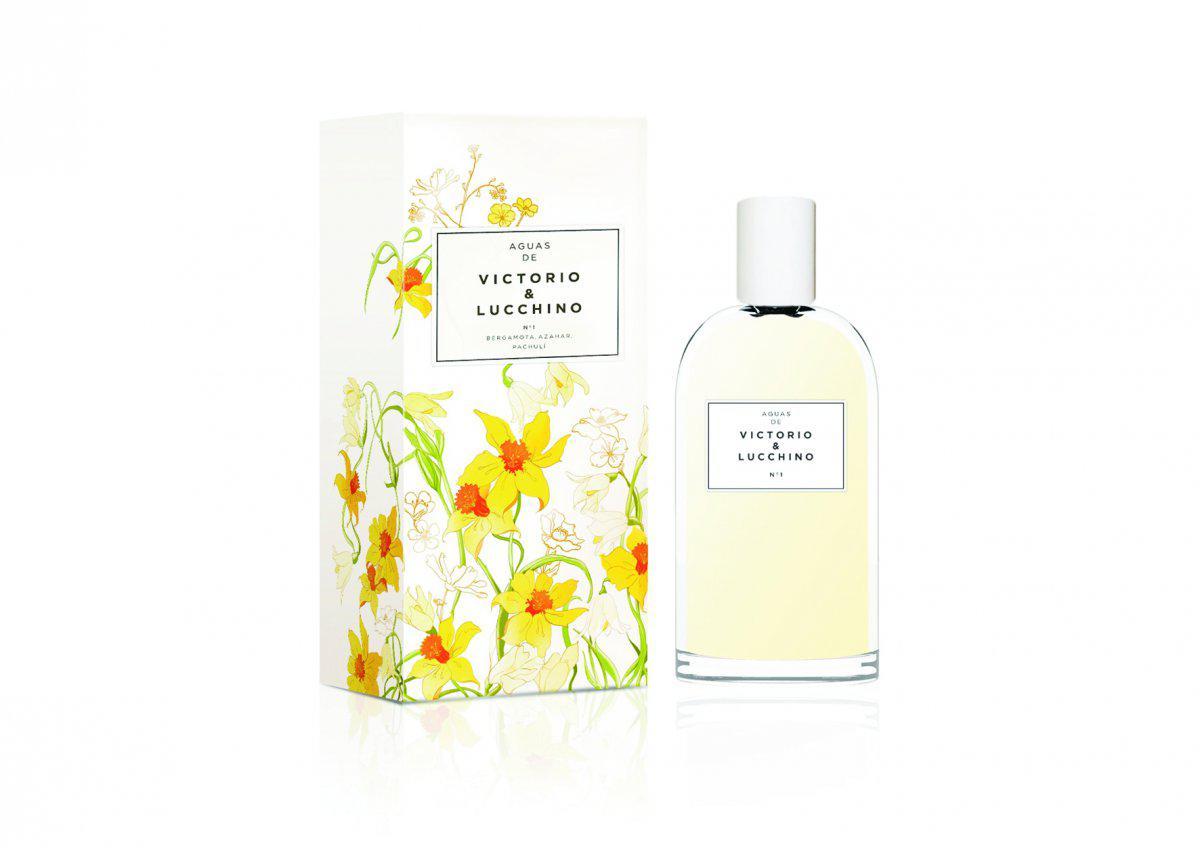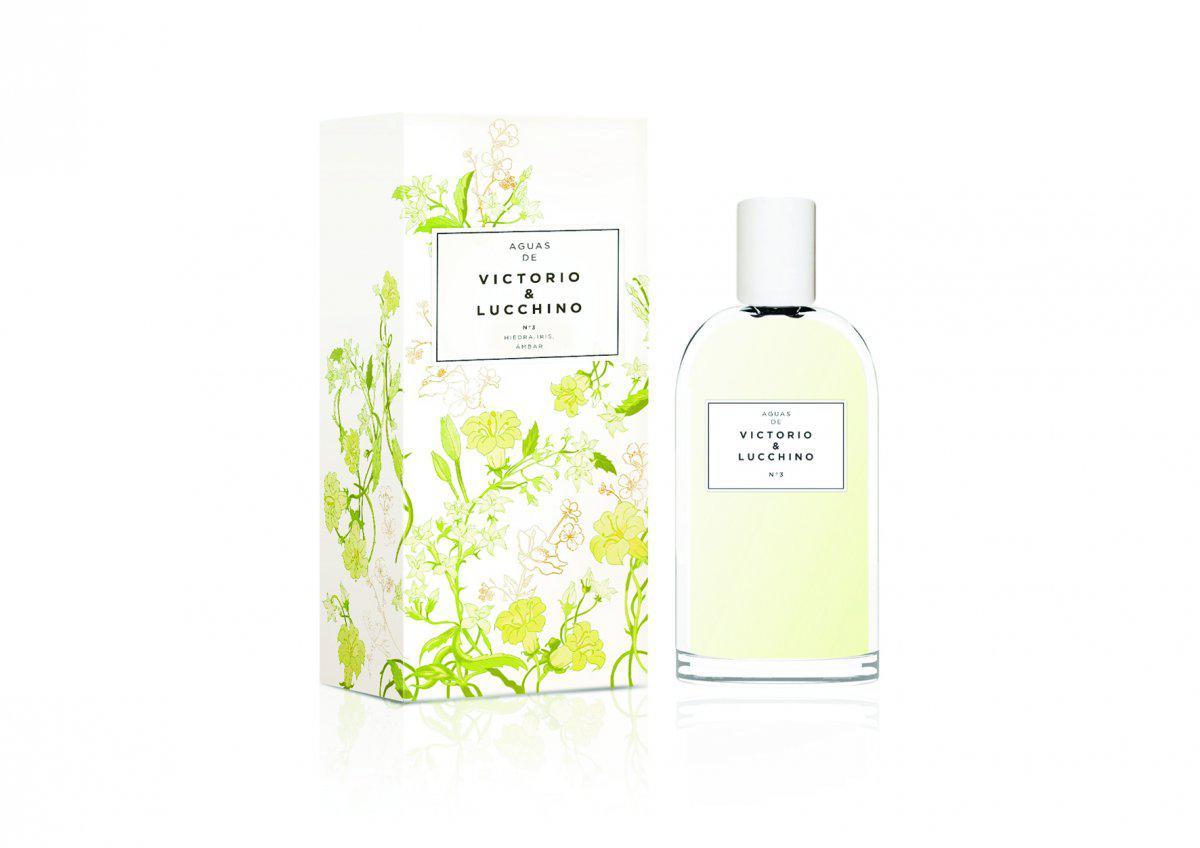The first image is the image on the left, the second image is the image on the right. Considering the images on both sides, is "One of the images shows three bottles of perfume surrounded by flowers." valid? Answer yes or no. No. 